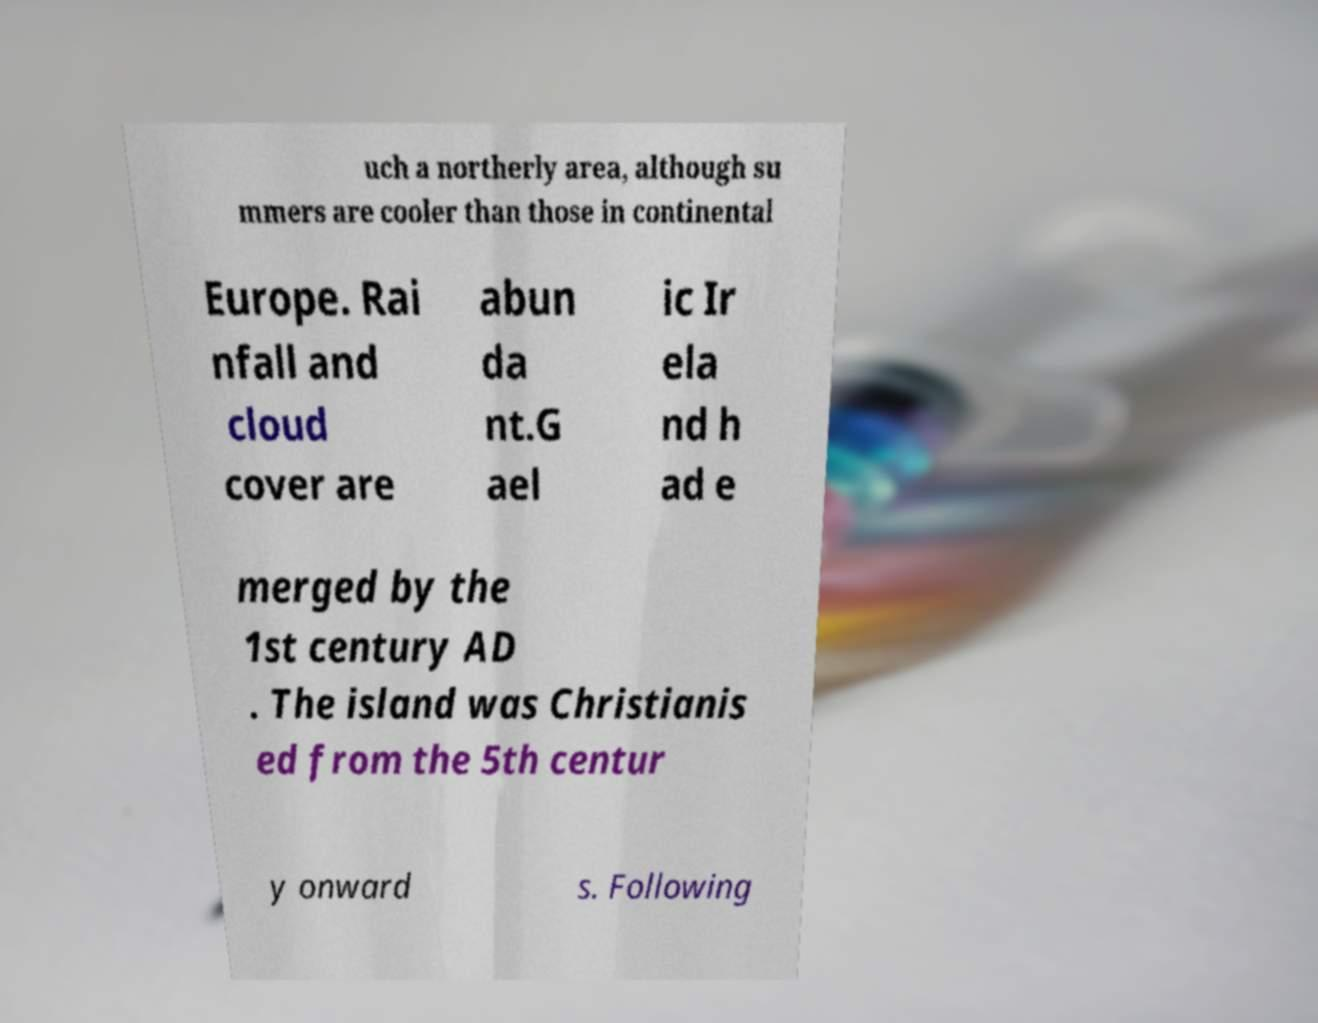Could you extract and type out the text from this image? uch a northerly area, although su mmers are cooler than those in continental Europe. Rai nfall and cloud cover are abun da nt.G ael ic Ir ela nd h ad e merged by the 1st century AD . The island was Christianis ed from the 5th centur y onward s. Following 